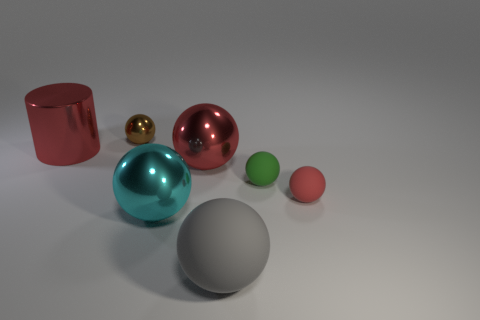Can you explain the possible composition of the large sphere in the foreground? The large sphere in the foreground has a diffused surface that absorbs light and has a non-reflective quality. This suggests a composition of perhaps a matte plastic, ceramic, or even a painted surface, giving it a subdued visual texture in contrast to the more reflective objects in the scene. 